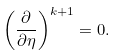Convert formula to latex. <formula><loc_0><loc_0><loc_500><loc_500>\left ( \frac { \partial } { \partial \eta } \right ) ^ { k + 1 } = 0 .</formula> 